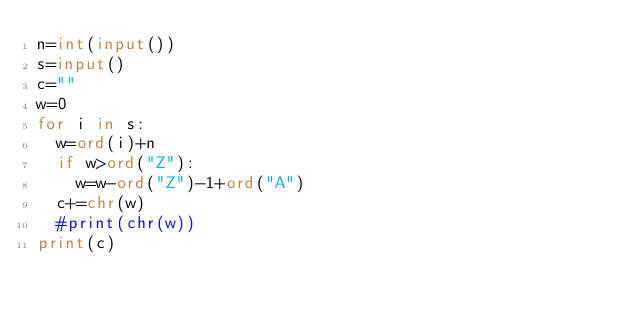<code> <loc_0><loc_0><loc_500><loc_500><_Python_>n=int(input())
s=input()
c=""
w=0
for i in s:
  w=ord(i)+n
  if w>ord("Z"):
    w=w-ord("Z")-1+ord("A")
  c+=chr(w)
  #print(chr(w))
print(c)
</code> 